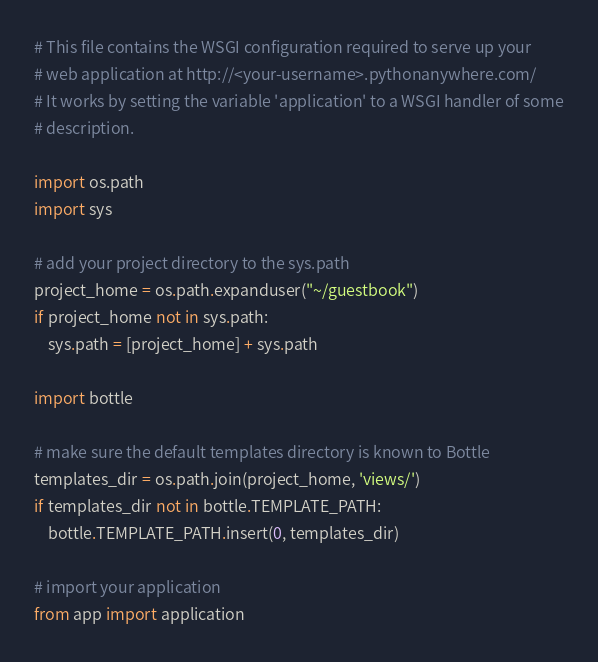Convert code to text. <code><loc_0><loc_0><loc_500><loc_500><_Python_># This file contains the WSGI configuration required to serve up your
# web application at http://<your-username>.pythonanywhere.com/
# It works by setting the variable 'application' to a WSGI handler of some
# description.

import os.path
import sys

# add your project directory to the sys.path
project_home = os.path.expanduser("~/guestbook")
if project_home not in sys.path:
    sys.path = [project_home] + sys.path

import bottle

# make sure the default templates directory is known to Bottle
templates_dir = os.path.join(project_home, 'views/')
if templates_dir not in bottle.TEMPLATE_PATH:
    bottle.TEMPLATE_PATH.insert(0, templates_dir)

# import your application
from app import application
</code> 